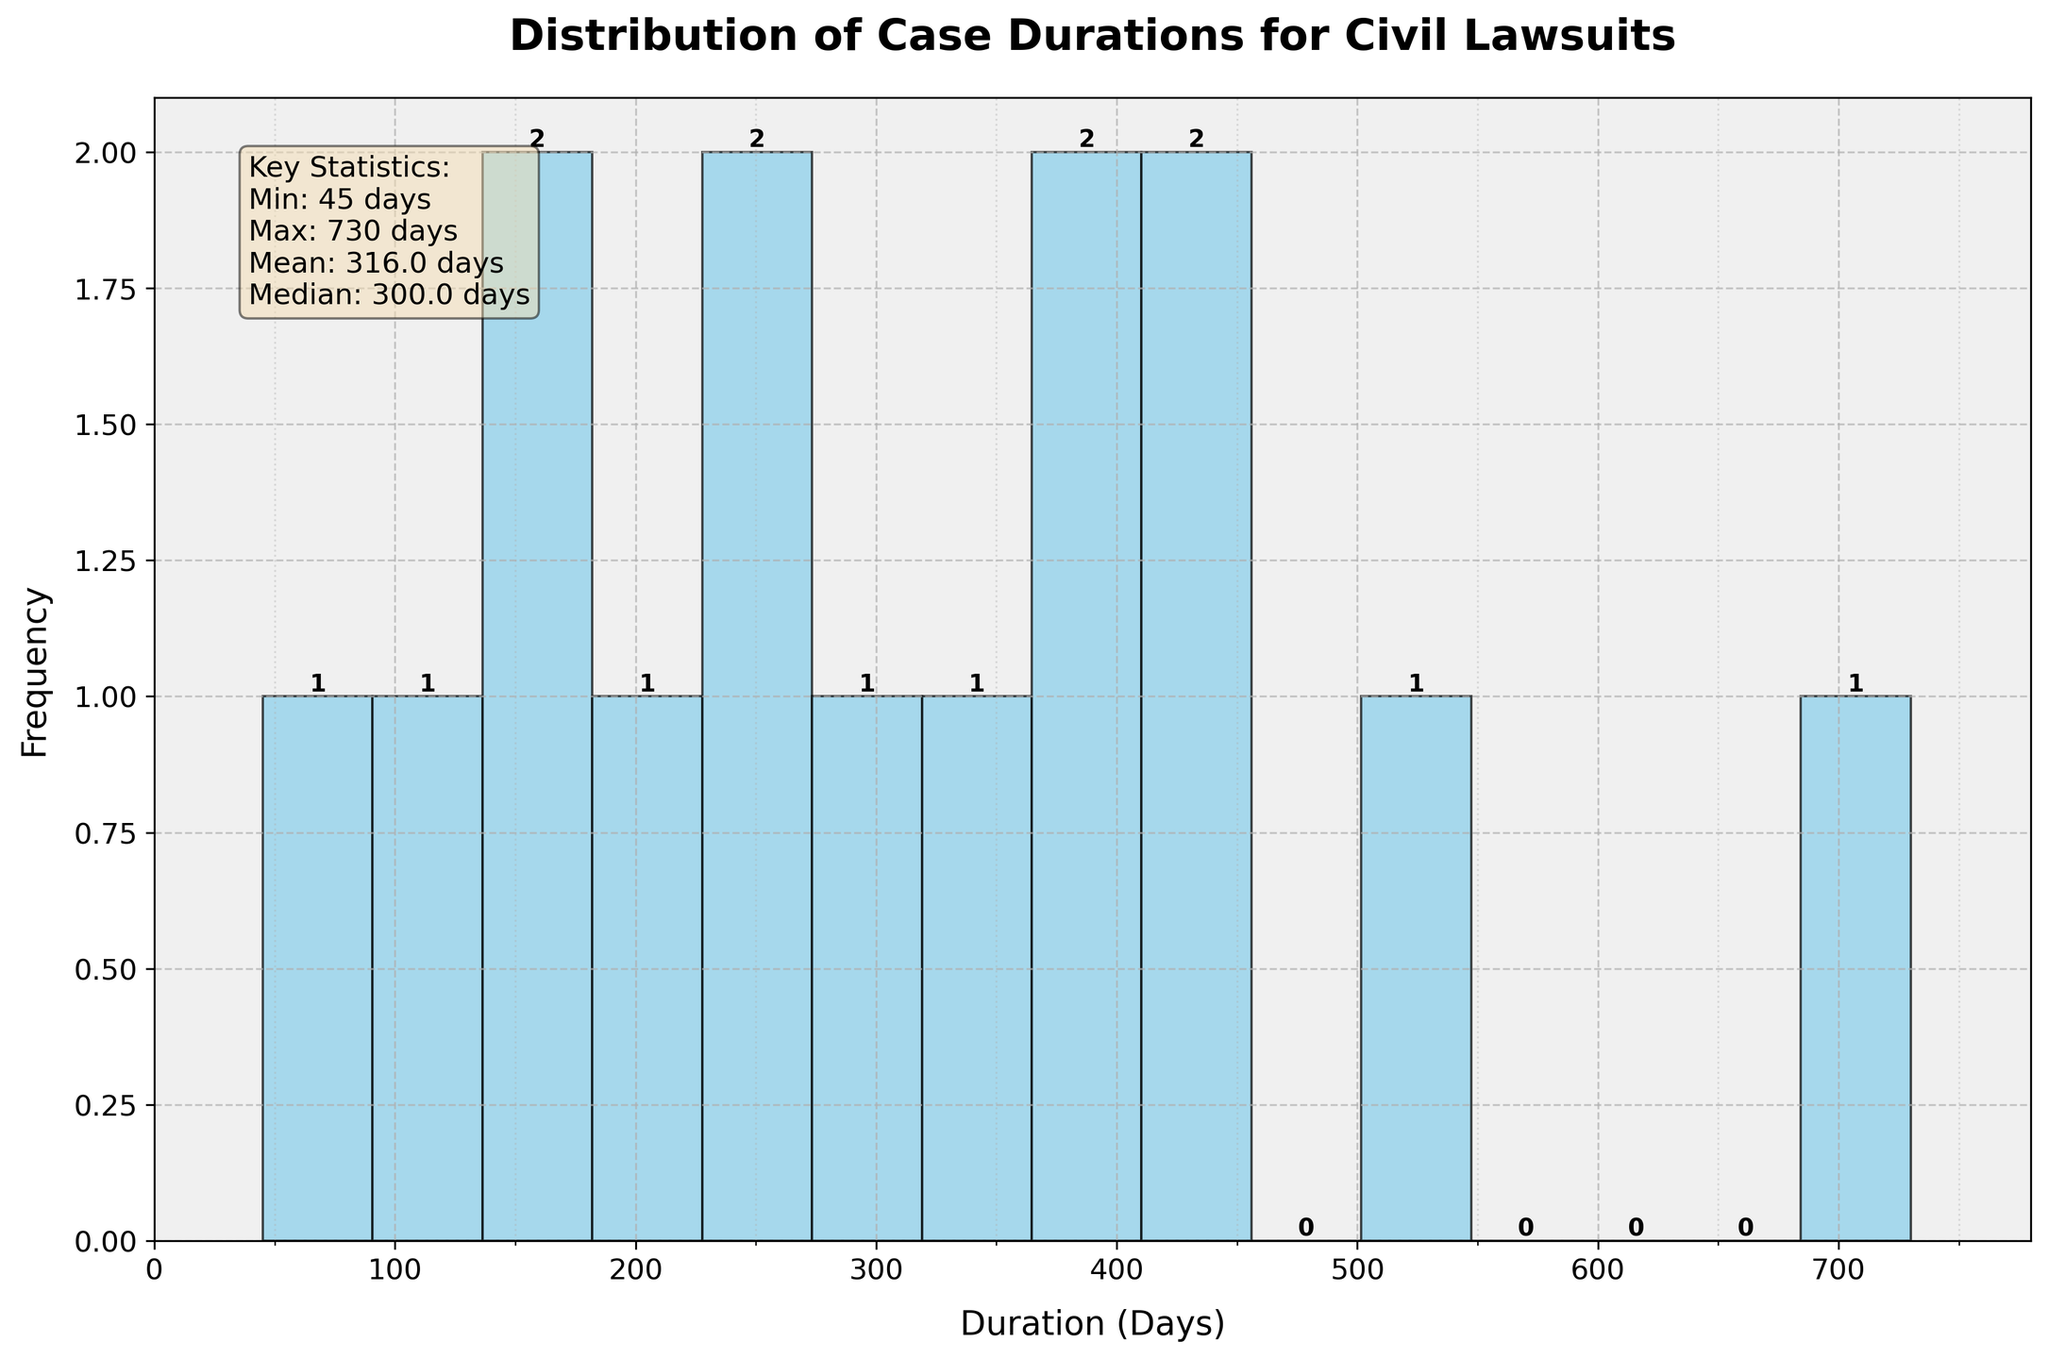What's the title of the plot? The title of the plot is located at the top of the figure and is usually in a larger and bold font, making it easily identifiable.
Answer: Distribution of Case Durations for Civil Lawsuits How many bins are there in the histogram? The number of bins can be counted by looking at the vertical bars in the histogram. Each bar represents one bin.
Answer: 15 What is the minimum duration of case types shown in the figure? The minimum duration is shown in the legend-like text box located on the figure, usually labeled as "Min". It's also the smallest value on the x-axis.
Answer: 45 days Which case type has the longest average duration? The longest duration can be found by identifying the highest value on the x-axis, which the histogram visualizes through the rightmost bin. Also, it can be cross-referenced with the case types listed in the data.
Answer: Complex Civil Litigation What is the width of each bin in the histogram? The width of each bin can be calculated by dividing the full range of durations by the number of bins. The x-axis range can be approximated from the bin limits.
Answer: Approximately 61.7 days How many case types fall into the 100-200 days duration bin? To find the frequency of case types in the specified bin, look at the height of the corresponding bar in the histogram and note the textual annotation above it.
Answer: 2 case types What is the mean value of the case durations? The mean value is provided in the legend-like text box in the figure and gives a summary statistic of the data.
Answer: 300 days What range of durations does the tallest bin cover and how many cases fall into it? The tallest bin's range can be identified from the x-axis limits of the bin. The height of the bin tells the count of cases, often annotated above the bar.
Answer: Approximately 250-300 days, 3 cases What is the median value of the case durations? The median value is provided in the legend-like text box in the figure, summarizing the midpoint of the data set.
Answer: 270 days Which bin has the least frequency and what is its range? The least frequent bin will be the shortest bar in the histogram, and its range can be identified from the x-axis limits of that bin.
Answer: Bin covering approximately 50-100 days, 1 case 